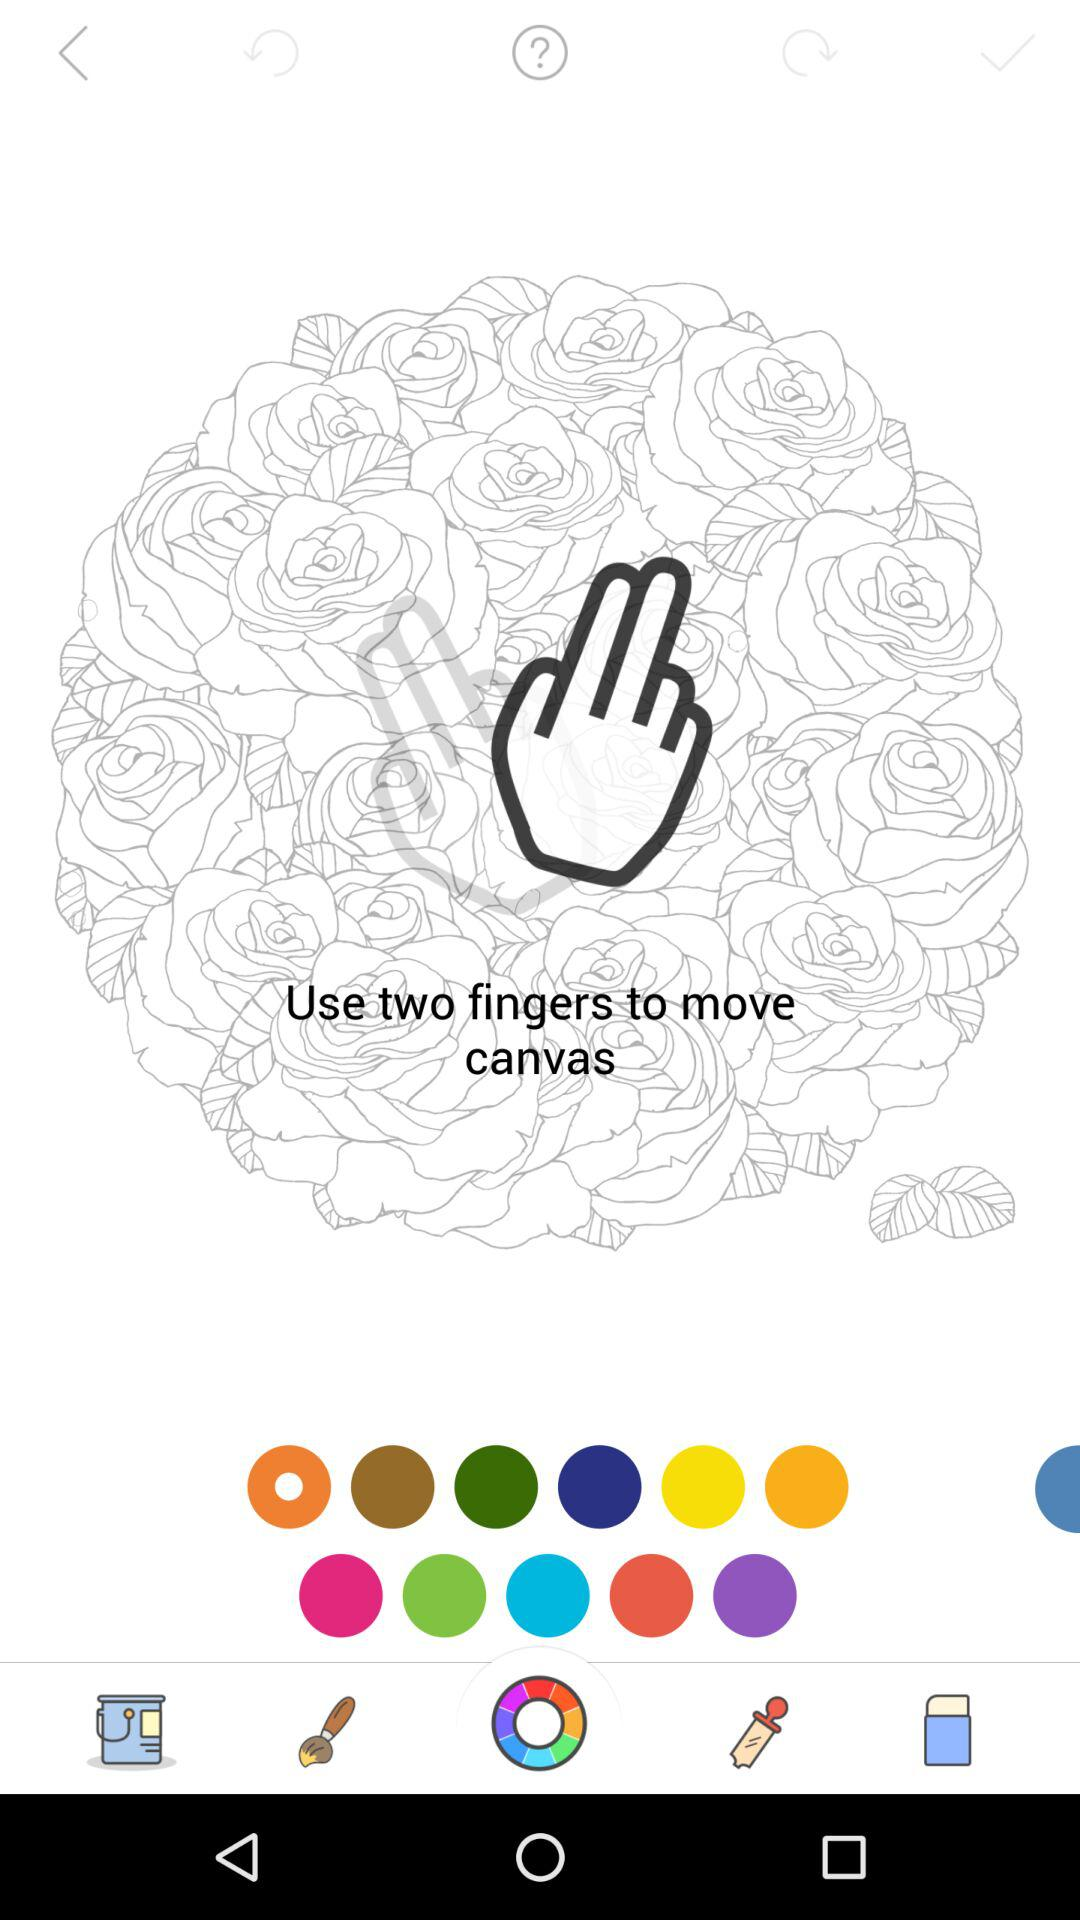How many tickets are left? There are 25 tickets left. 